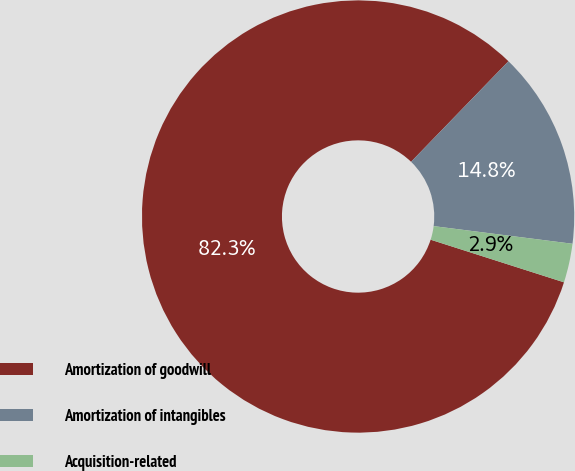Convert chart. <chart><loc_0><loc_0><loc_500><loc_500><pie_chart><fcel>Amortization of goodwill<fcel>Amortization of intangibles<fcel>Acquisition-related<nl><fcel>82.32%<fcel>14.77%<fcel>2.91%<nl></chart> 